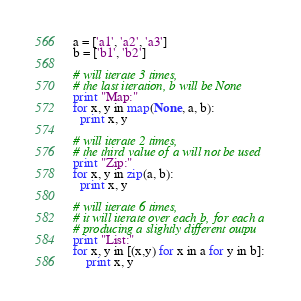<code> <loc_0><loc_0><loc_500><loc_500><_Python_>a = ['a1', 'a2', 'a3']
b = ['b1', 'b2']

# will iterate 3 times,
# the last iteration, b will be None
print "Map:"
for x, y in map(None, a, b):
  print x, y

# will iterate 2 times,
# the third value of a will not be used
print "Zip:"
for x, y in zip(a, b):
  print x, y

# will iterate 6 times,
# it will iterate over each b, for each a
# producing a slightly different outpu
print "List:"
for x, y in [(x,y) for x in a for y in b]:
    print x, y
</code> 